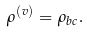Convert formula to latex. <formula><loc_0><loc_0><loc_500><loc_500>\rho ^ { ( v ) } = \rho _ { b c } .</formula> 